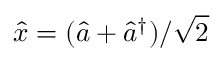Convert formula to latex. <formula><loc_0><loc_0><loc_500><loc_500>\hat { x } = ( \hat { a } + \hat { a } ^ { \dagger } ) / \sqrt { 2 }</formula> 